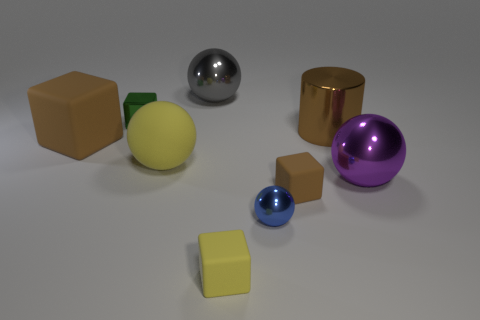Can you tell me which objects might be the heaviest and lightest based on their material and size? Judging by their material and size, the golden cylinder may be the heaviest if it is made of metal, and the small yellow cube might be the lightest, especially if it's made of a light material like plastic. Considering they are all made of the same material, how would their weight compare? If the objects were all made of the same material, their weight would mainly depend on their size and volume. The large brown cube would be the heaviest due to its larger size and volume, while the smaller blue sphere would likely be the lightest. 